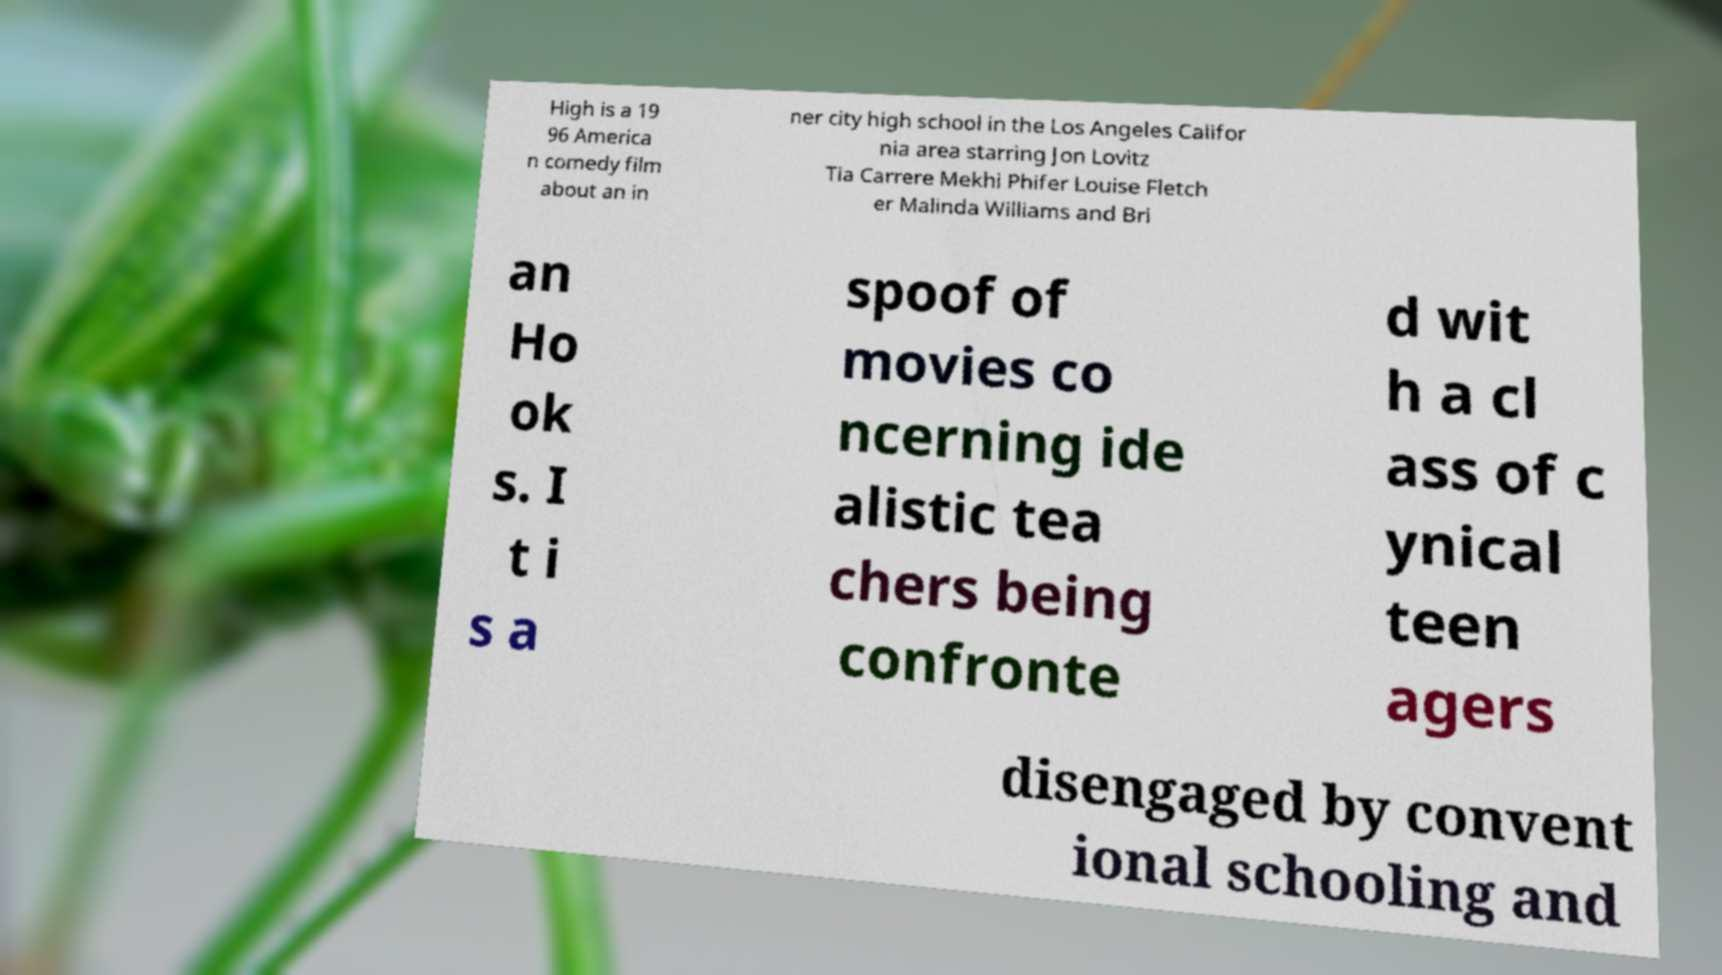Could you extract and type out the text from this image? High is a 19 96 America n comedy film about an in ner city high school in the Los Angeles Califor nia area starring Jon Lovitz Tia Carrere Mekhi Phifer Louise Fletch er Malinda Williams and Bri an Ho ok s. I t i s a spoof of movies co ncerning ide alistic tea chers being confronte d wit h a cl ass of c ynical teen agers disengaged by convent ional schooling and 